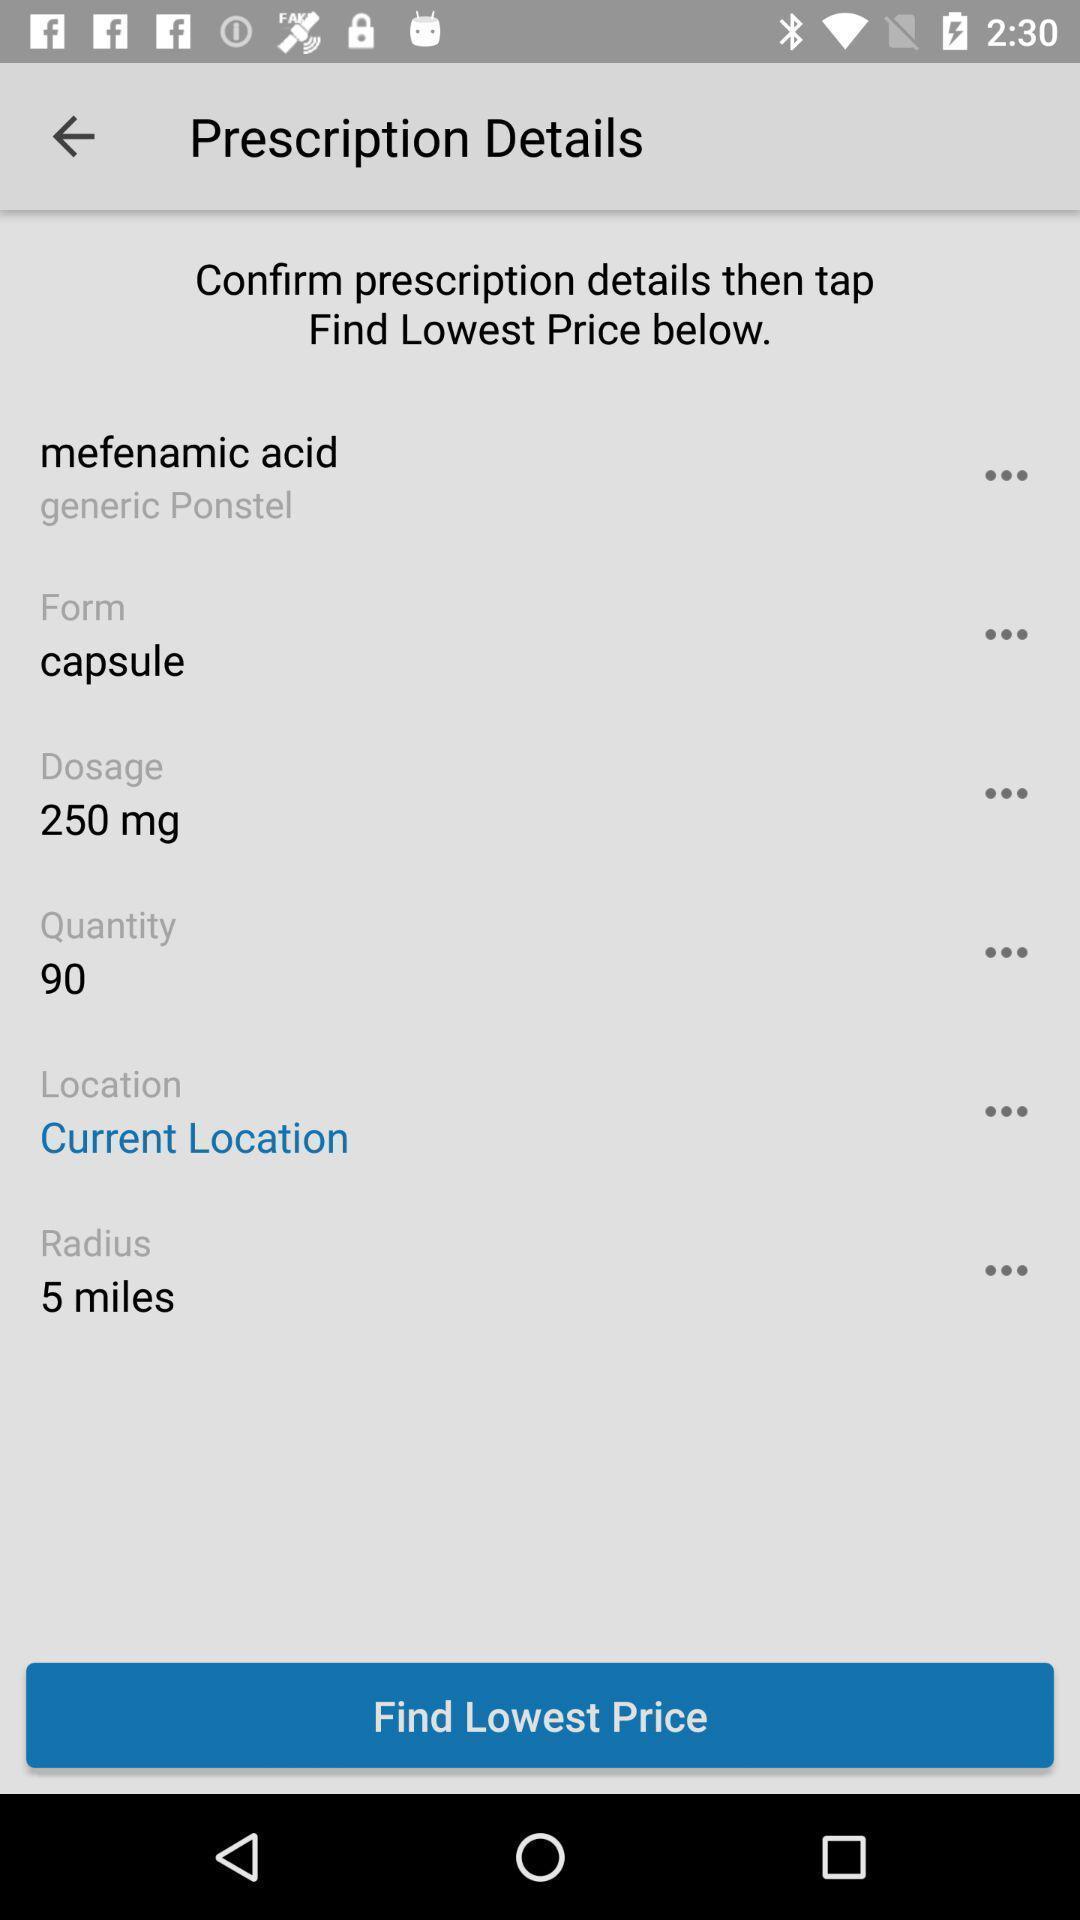Explain the elements present in this screenshot. Screen shows prescription details in a health app. 